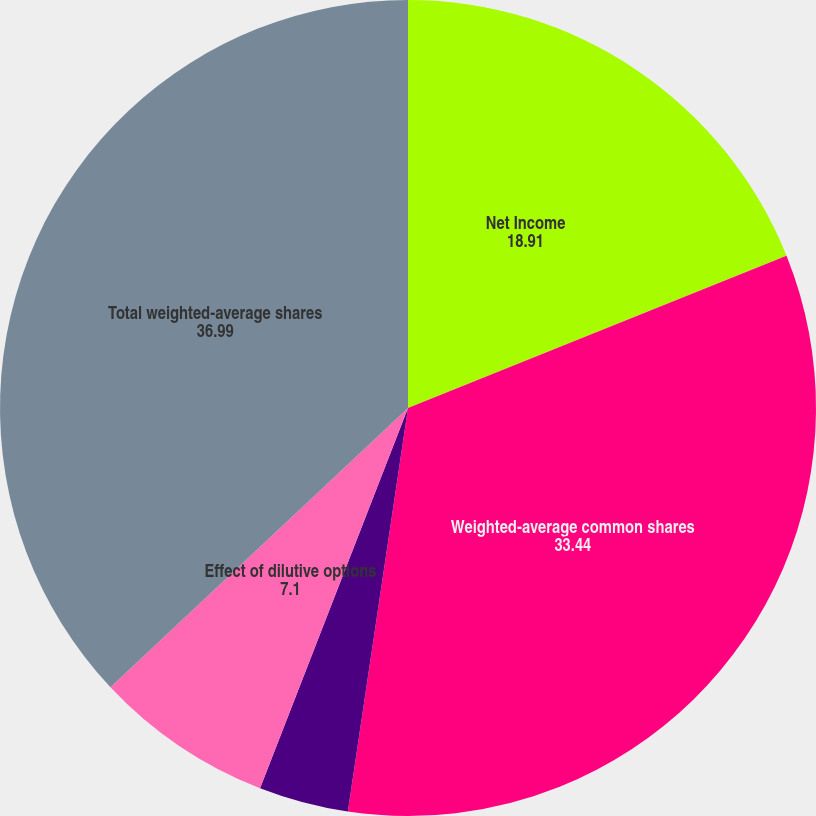<chart> <loc_0><loc_0><loc_500><loc_500><pie_chart><fcel>Net Income<fcel>Weighted-average common shares<fcel>Basic earnings per share<fcel>Effect of dilutive options<fcel>Total weighted-average shares<fcel>Diluted earnings per share<nl><fcel>18.91%<fcel>33.44%<fcel>3.55%<fcel>7.1%<fcel>36.99%<fcel>0.0%<nl></chart> 